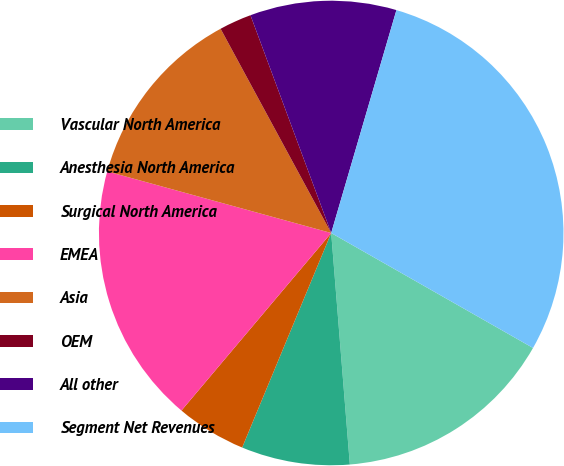Convert chart. <chart><loc_0><loc_0><loc_500><loc_500><pie_chart><fcel>Vascular North America<fcel>Anesthesia North America<fcel>Surgical North America<fcel>EMEA<fcel>Asia<fcel>OEM<fcel>All other<fcel>Segment Net Revenues<nl><fcel>15.48%<fcel>7.54%<fcel>4.89%<fcel>18.12%<fcel>12.83%<fcel>2.25%<fcel>10.18%<fcel>28.71%<nl></chart> 